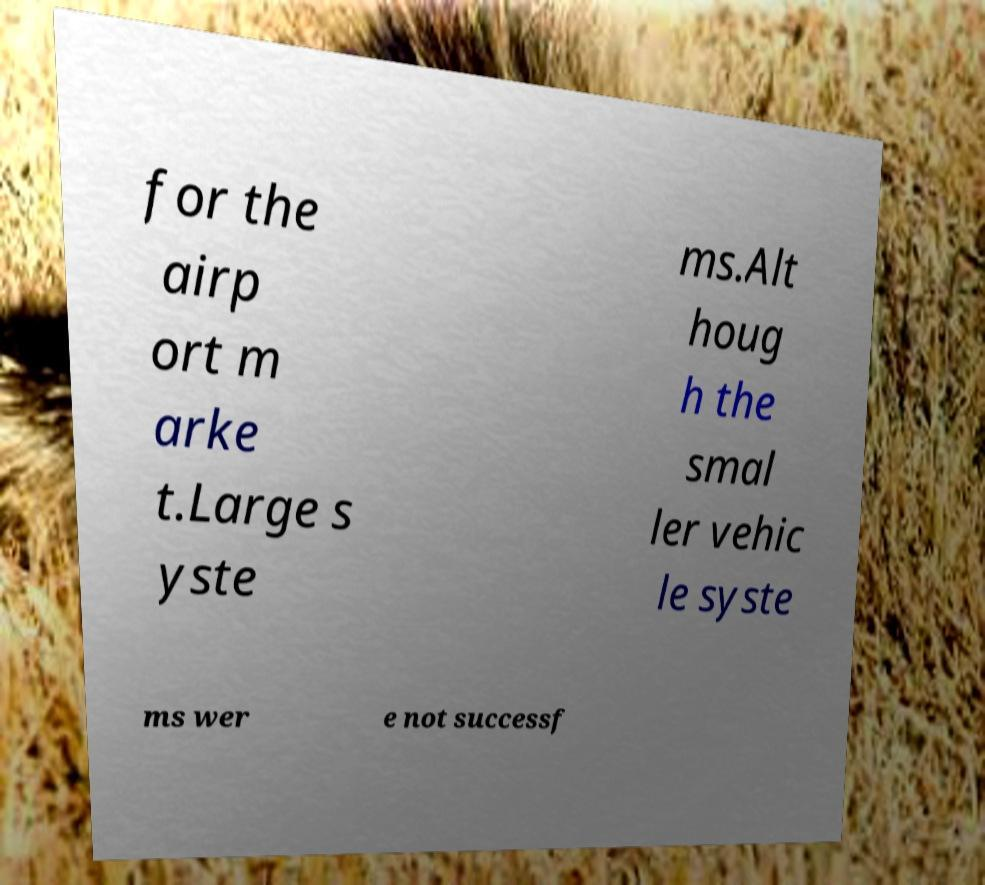Could you assist in decoding the text presented in this image and type it out clearly? for the airp ort m arke t.Large s yste ms.Alt houg h the smal ler vehic le syste ms wer e not successf 